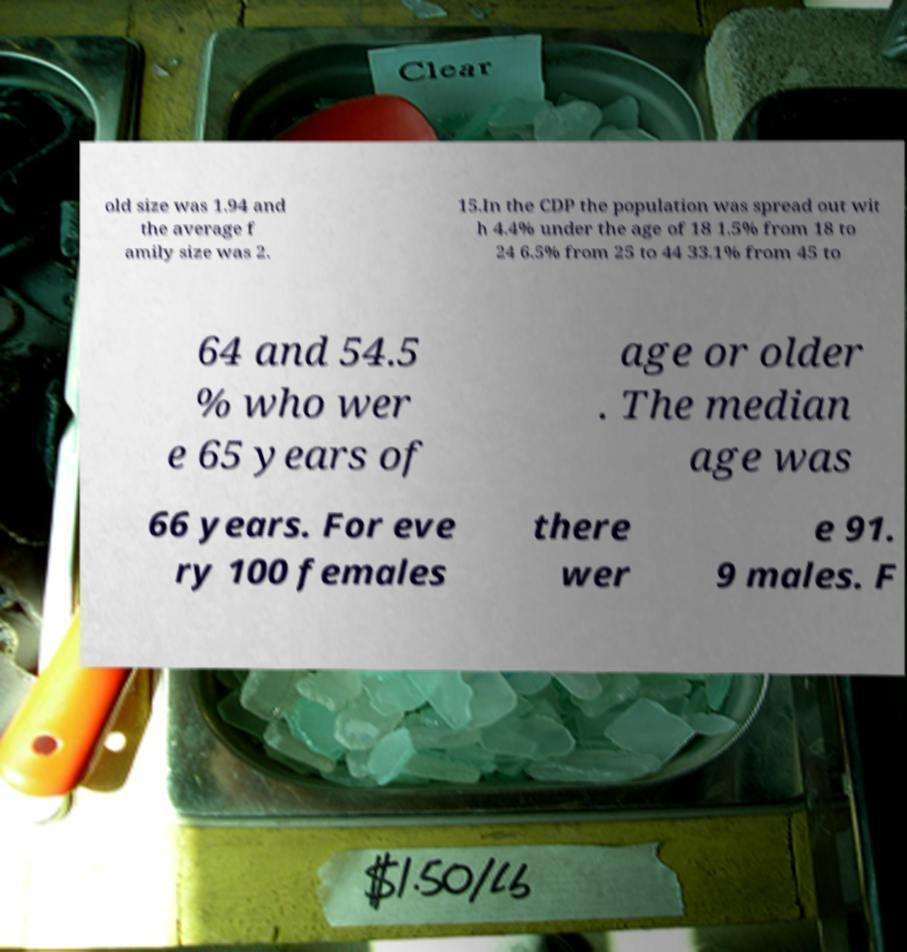Could you extract and type out the text from this image? old size was 1.94 and the average f amily size was 2. 15.In the CDP the population was spread out wit h 4.4% under the age of 18 1.5% from 18 to 24 6.5% from 25 to 44 33.1% from 45 to 64 and 54.5 % who wer e 65 years of age or older . The median age was 66 years. For eve ry 100 females there wer e 91. 9 males. F 